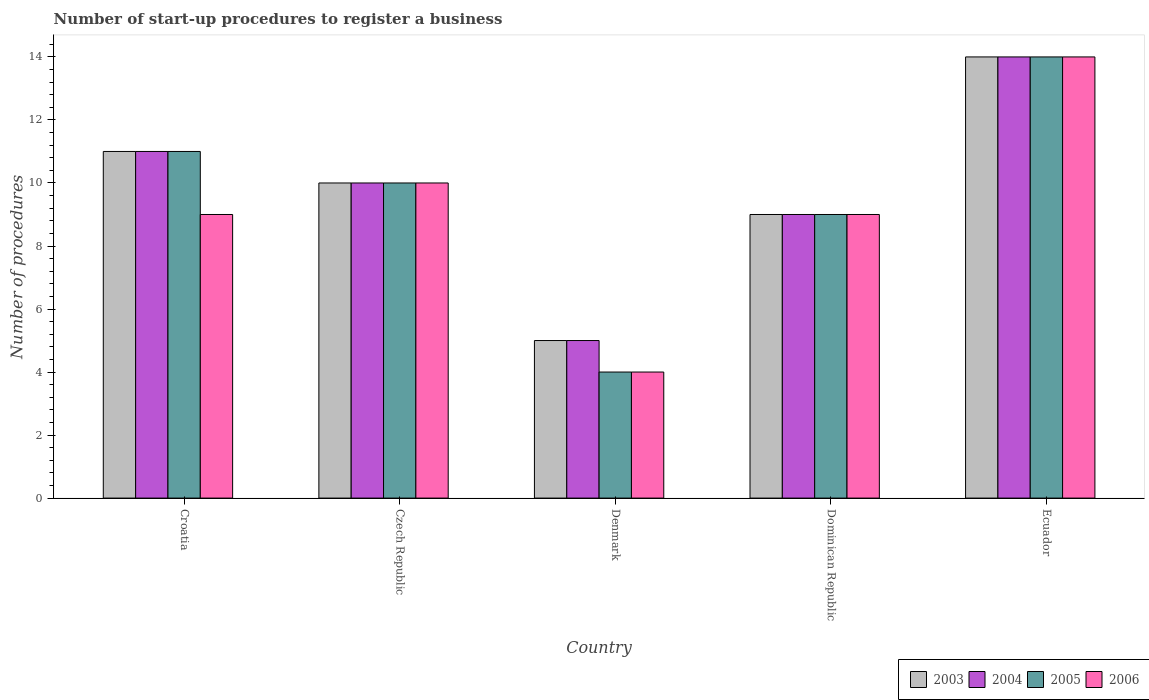How many different coloured bars are there?
Provide a succinct answer. 4. How many groups of bars are there?
Provide a succinct answer. 5. Are the number of bars on each tick of the X-axis equal?
Offer a terse response. Yes. In how many cases, is the number of bars for a given country not equal to the number of legend labels?
Make the answer very short. 0. Across all countries, what is the maximum number of procedures required to register a business in 2003?
Make the answer very short. 14. Across all countries, what is the minimum number of procedures required to register a business in 2005?
Offer a terse response. 4. In which country was the number of procedures required to register a business in 2004 maximum?
Your answer should be compact. Ecuador. In which country was the number of procedures required to register a business in 2005 minimum?
Keep it short and to the point. Denmark. What is the total number of procedures required to register a business in 2004 in the graph?
Make the answer very short. 49. What is the difference between the number of procedures required to register a business in 2005 in Croatia and the number of procedures required to register a business in 2003 in Ecuador?
Give a very brief answer. -3. What is the average number of procedures required to register a business in 2003 per country?
Provide a succinct answer. 9.8. What is the difference between the highest and the lowest number of procedures required to register a business in 2006?
Offer a terse response. 10. In how many countries, is the number of procedures required to register a business in 2006 greater than the average number of procedures required to register a business in 2006 taken over all countries?
Provide a short and direct response. 2. Is the sum of the number of procedures required to register a business in 2004 in Croatia and Ecuador greater than the maximum number of procedures required to register a business in 2005 across all countries?
Provide a succinct answer. Yes. Is it the case that in every country, the sum of the number of procedures required to register a business in 2003 and number of procedures required to register a business in 2006 is greater than the sum of number of procedures required to register a business in 2004 and number of procedures required to register a business in 2005?
Provide a succinct answer. No. What does the 4th bar from the right in Croatia represents?
Your answer should be compact. 2003. How many bars are there?
Provide a short and direct response. 20. How many countries are there in the graph?
Provide a short and direct response. 5. Does the graph contain any zero values?
Your answer should be compact. No. What is the title of the graph?
Your answer should be very brief. Number of start-up procedures to register a business. What is the label or title of the Y-axis?
Offer a terse response. Number of procedures. What is the Number of procedures in 2005 in Croatia?
Keep it short and to the point. 11. What is the Number of procedures in 2003 in Czech Republic?
Offer a very short reply. 10. What is the Number of procedures of 2004 in Czech Republic?
Your response must be concise. 10. What is the Number of procedures in 2004 in Denmark?
Your answer should be very brief. 5. What is the Number of procedures of 2004 in Dominican Republic?
Your answer should be very brief. 9. What is the Number of procedures of 2005 in Dominican Republic?
Provide a succinct answer. 9. What is the Number of procedures of 2003 in Ecuador?
Keep it short and to the point. 14. What is the Number of procedures of 2005 in Ecuador?
Your answer should be compact. 14. What is the Number of procedures in 2006 in Ecuador?
Your answer should be very brief. 14. Across all countries, what is the minimum Number of procedures of 2004?
Your answer should be very brief. 5. Across all countries, what is the minimum Number of procedures in 2005?
Keep it short and to the point. 4. What is the total Number of procedures in 2006 in the graph?
Your response must be concise. 46. What is the difference between the Number of procedures of 2003 in Croatia and that in Czech Republic?
Provide a short and direct response. 1. What is the difference between the Number of procedures in 2005 in Croatia and that in Czech Republic?
Offer a terse response. 1. What is the difference between the Number of procedures of 2005 in Croatia and that in Denmark?
Provide a short and direct response. 7. What is the difference between the Number of procedures in 2006 in Croatia and that in Denmark?
Offer a terse response. 5. What is the difference between the Number of procedures in 2003 in Croatia and that in Ecuador?
Provide a short and direct response. -3. What is the difference between the Number of procedures of 2006 in Croatia and that in Ecuador?
Give a very brief answer. -5. What is the difference between the Number of procedures in 2003 in Czech Republic and that in Denmark?
Your answer should be compact. 5. What is the difference between the Number of procedures in 2005 in Czech Republic and that in Denmark?
Keep it short and to the point. 6. What is the difference between the Number of procedures in 2003 in Czech Republic and that in Dominican Republic?
Provide a short and direct response. 1. What is the difference between the Number of procedures in 2004 in Czech Republic and that in Dominican Republic?
Offer a very short reply. 1. What is the difference between the Number of procedures of 2005 in Czech Republic and that in Dominican Republic?
Keep it short and to the point. 1. What is the difference between the Number of procedures in 2006 in Czech Republic and that in Dominican Republic?
Your answer should be compact. 1. What is the difference between the Number of procedures of 2005 in Czech Republic and that in Ecuador?
Make the answer very short. -4. What is the difference between the Number of procedures of 2006 in Czech Republic and that in Ecuador?
Give a very brief answer. -4. What is the difference between the Number of procedures of 2004 in Denmark and that in Ecuador?
Provide a short and direct response. -9. What is the difference between the Number of procedures in 2006 in Denmark and that in Ecuador?
Your response must be concise. -10. What is the difference between the Number of procedures of 2003 in Dominican Republic and that in Ecuador?
Your response must be concise. -5. What is the difference between the Number of procedures in 2003 in Croatia and the Number of procedures in 2006 in Czech Republic?
Offer a very short reply. 1. What is the difference between the Number of procedures in 2004 in Croatia and the Number of procedures in 2006 in Czech Republic?
Provide a succinct answer. 1. What is the difference between the Number of procedures of 2003 in Croatia and the Number of procedures of 2004 in Denmark?
Keep it short and to the point. 6. What is the difference between the Number of procedures in 2003 in Croatia and the Number of procedures in 2006 in Denmark?
Offer a very short reply. 7. What is the difference between the Number of procedures in 2004 in Croatia and the Number of procedures in 2006 in Denmark?
Provide a succinct answer. 7. What is the difference between the Number of procedures of 2003 in Croatia and the Number of procedures of 2004 in Dominican Republic?
Offer a terse response. 2. What is the difference between the Number of procedures in 2003 in Croatia and the Number of procedures in 2006 in Dominican Republic?
Make the answer very short. 2. What is the difference between the Number of procedures in 2004 in Croatia and the Number of procedures in 2005 in Dominican Republic?
Offer a terse response. 2. What is the difference between the Number of procedures of 2004 in Croatia and the Number of procedures of 2006 in Dominican Republic?
Your answer should be compact. 2. What is the difference between the Number of procedures in 2005 in Croatia and the Number of procedures in 2006 in Dominican Republic?
Keep it short and to the point. 2. What is the difference between the Number of procedures in 2004 in Croatia and the Number of procedures in 2005 in Ecuador?
Your answer should be very brief. -3. What is the difference between the Number of procedures in 2004 in Croatia and the Number of procedures in 2006 in Ecuador?
Offer a terse response. -3. What is the difference between the Number of procedures of 2005 in Croatia and the Number of procedures of 2006 in Ecuador?
Keep it short and to the point. -3. What is the difference between the Number of procedures in 2003 in Czech Republic and the Number of procedures in 2004 in Denmark?
Offer a very short reply. 5. What is the difference between the Number of procedures of 2003 in Czech Republic and the Number of procedures of 2005 in Denmark?
Provide a succinct answer. 6. What is the difference between the Number of procedures of 2004 in Czech Republic and the Number of procedures of 2005 in Denmark?
Ensure brevity in your answer.  6. What is the difference between the Number of procedures in 2003 in Czech Republic and the Number of procedures in 2006 in Dominican Republic?
Your answer should be very brief. 1. What is the difference between the Number of procedures in 2004 in Czech Republic and the Number of procedures in 2006 in Dominican Republic?
Give a very brief answer. 1. What is the difference between the Number of procedures of 2005 in Czech Republic and the Number of procedures of 2006 in Dominican Republic?
Offer a terse response. 1. What is the difference between the Number of procedures of 2003 in Czech Republic and the Number of procedures of 2004 in Ecuador?
Your answer should be compact. -4. What is the difference between the Number of procedures of 2003 in Czech Republic and the Number of procedures of 2005 in Ecuador?
Offer a terse response. -4. What is the difference between the Number of procedures of 2004 in Czech Republic and the Number of procedures of 2005 in Ecuador?
Offer a terse response. -4. What is the difference between the Number of procedures of 2005 in Czech Republic and the Number of procedures of 2006 in Ecuador?
Offer a terse response. -4. What is the difference between the Number of procedures of 2003 in Denmark and the Number of procedures of 2004 in Dominican Republic?
Your answer should be very brief. -4. What is the difference between the Number of procedures of 2004 in Denmark and the Number of procedures of 2005 in Dominican Republic?
Give a very brief answer. -4. What is the difference between the Number of procedures in 2003 in Denmark and the Number of procedures in 2004 in Ecuador?
Give a very brief answer. -9. What is the difference between the Number of procedures in 2003 in Denmark and the Number of procedures in 2005 in Ecuador?
Provide a succinct answer. -9. What is the difference between the Number of procedures of 2003 in Denmark and the Number of procedures of 2006 in Ecuador?
Provide a succinct answer. -9. What is the difference between the Number of procedures of 2004 in Denmark and the Number of procedures of 2005 in Ecuador?
Give a very brief answer. -9. What is the difference between the Number of procedures in 2004 in Denmark and the Number of procedures in 2006 in Ecuador?
Your answer should be very brief. -9. What is the difference between the Number of procedures of 2003 in Dominican Republic and the Number of procedures of 2004 in Ecuador?
Your answer should be very brief. -5. What is the difference between the Number of procedures in 2003 in Dominican Republic and the Number of procedures in 2005 in Ecuador?
Provide a succinct answer. -5. What is the difference between the Number of procedures of 2003 in Dominican Republic and the Number of procedures of 2006 in Ecuador?
Ensure brevity in your answer.  -5. What is the difference between the Number of procedures in 2004 in Dominican Republic and the Number of procedures in 2005 in Ecuador?
Your answer should be compact. -5. What is the average Number of procedures of 2003 per country?
Your answer should be very brief. 9.8. What is the average Number of procedures of 2004 per country?
Your response must be concise. 9.8. What is the average Number of procedures of 2005 per country?
Your answer should be very brief. 9.6. What is the average Number of procedures in 2006 per country?
Your answer should be compact. 9.2. What is the difference between the Number of procedures of 2003 and Number of procedures of 2004 in Croatia?
Provide a succinct answer. 0. What is the difference between the Number of procedures of 2003 and Number of procedures of 2005 in Croatia?
Keep it short and to the point. 0. What is the difference between the Number of procedures in 2003 and Number of procedures in 2006 in Croatia?
Ensure brevity in your answer.  2. What is the difference between the Number of procedures of 2004 and Number of procedures of 2006 in Croatia?
Offer a terse response. 2. What is the difference between the Number of procedures in 2005 and Number of procedures in 2006 in Croatia?
Offer a terse response. 2. What is the difference between the Number of procedures of 2003 and Number of procedures of 2006 in Czech Republic?
Your answer should be very brief. 0. What is the difference between the Number of procedures of 2005 and Number of procedures of 2006 in Czech Republic?
Offer a very short reply. 0. What is the difference between the Number of procedures in 2003 and Number of procedures in 2005 in Denmark?
Provide a succinct answer. 1. What is the difference between the Number of procedures in 2004 and Number of procedures in 2005 in Denmark?
Provide a succinct answer. 1. What is the difference between the Number of procedures of 2004 and Number of procedures of 2006 in Denmark?
Keep it short and to the point. 1. What is the difference between the Number of procedures in 2003 and Number of procedures in 2004 in Dominican Republic?
Make the answer very short. 0. What is the difference between the Number of procedures in 2003 and Number of procedures in 2005 in Dominican Republic?
Your answer should be very brief. 0. What is the difference between the Number of procedures of 2004 and Number of procedures of 2006 in Dominican Republic?
Your answer should be very brief. 0. What is the difference between the Number of procedures in 2005 and Number of procedures in 2006 in Dominican Republic?
Keep it short and to the point. 0. What is the difference between the Number of procedures in 2003 and Number of procedures in 2006 in Ecuador?
Ensure brevity in your answer.  0. What is the difference between the Number of procedures in 2004 and Number of procedures in 2006 in Ecuador?
Your response must be concise. 0. What is the ratio of the Number of procedures in 2003 in Croatia to that in Czech Republic?
Your answer should be compact. 1.1. What is the ratio of the Number of procedures in 2005 in Croatia to that in Czech Republic?
Make the answer very short. 1.1. What is the ratio of the Number of procedures in 2006 in Croatia to that in Czech Republic?
Keep it short and to the point. 0.9. What is the ratio of the Number of procedures of 2004 in Croatia to that in Denmark?
Provide a succinct answer. 2.2. What is the ratio of the Number of procedures in 2005 in Croatia to that in Denmark?
Your answer should be compact. 2.75. What is the ratio of the Number of procedures of 2006 in Croatia to that in Denmark?
Your answer should be very brief. 2.25. What is the ratio of the Number of procedures in 2003 in Croatia to that in Dominican Republic?
Provide a succinct answer. 1.22. What is the ratio of the Number of procedures of 2004 in Croatia to that in Dominican Republic?
Offer a very short reply. 1.22. What is the ratio of the Number of procedures in 2005 in Croatia to that in Dominican Republic?
Provide a succinct answer. 1.22. What is the ratio of the Number of procedures of 2006 in Croatia to that in Dominican Republic?
Keep it short and to the point. 1. What is the ratio of the Number of procedures in 2003 in Croatia to that in Ecuador?
Offer a terse response. 0.79. What is the ratio of the Number of procedures in 2004 in Croatia to that in Ecuador?
Give a very brief answer. 0.79. What is the ratio of the Number of procedures in 2005 in Croatia to that in Ecuador?
Provide a succinct answer. 0.79. What is the ratio of the Number of procedures in 2006 in Croatia to that in Ecuador?
Ensure brevity in your answer.  0.64. What is the ratio of the Number of procedures in 2006 in Czech Republic to that in Denmark?
Make the answer very short. 2.5. What is the ratio of the Number of procedures in 2006 in Czech Republic to that in Dominican Republic?
Your answer should be very brief. 1.11. What is the ratio of the Number of procedures in 2005 in Czech Republic to that in Ecuador?
Make the answer very short. 0.71. What is the ratio of the Number of procedures of 2006 in Czech Republic to that in Ecuador?
Your answer should be very brief. 0.71. What is the ratio of the Number of procedures in 2003 in Denmark to that in Dominican Republic?
Keep it short and to the point. 0.56. What is the ratio of the Number of procedures in 2004 in Denmark to that in Dominican Republic?
Make the answer very short. 0.56. What is the ratio of the Number of procedures in 2005 in Denmark to that in Dominican Republic?
Your answer should be very brief. 0.44. What is the ratio of the Number of procedures of 2006 in Denmark to that in Dominican Republic?
Ensure brevity in your answer.  0.44. What is the ratio of the Number of procedures of 2003 in Denmark to that in Ecuador?
Provide a short and direct response. 0.36. What is the ratio of the Number of procedures in 2004 in Denmark to that in Ecuador?
Offer a very short reply. 0.36. What is the ratio of the Number of procedures in 2005 in Denmark to that in Ecuador?
Provide a succinct answer. 0.29. What is the ratio of the Number of procedures of 2006 in Denmark to that in Ecuador?
Provide a succinct answer. 0.29. What is the ratio of the Number of procedures of 2003 in Dominican Republic to that in Ecuador?
Your answer should be compact. 0.64. What is the ratio of the Number of procedures in 2004 in Dominican Republic to that in Ecuador?
Keep it short and to the point. 0.64. What is the ratio of the Number of procedures in 2005 in Dominican Republic to that in Ecuador?
Provide a succinct answer. 0.64. What is the ratio of the Number of procedures of 2006 in Dominican Republic to that in Ecuador?
Give a very brief answer. 0.64. What is the difference between the highest and the second highest Number of procedures in 2003?
Provide a short and direct response. 3. What is the difference between the highest and the second highest Number of procedures of 2004?
Make the answer very short. 3. What is the difference between the highest and the second highest Number of procedures in 2005?
Provide a short and direct response. 3. What is the difference between the highest and the lowest Number of procedures of 2003?
Offer a very short reply. 9. What is the difference between the highest and the lowest Number of procedures in 2005?
Provide a short and direct response. 10. 